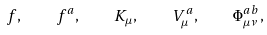<formula> <loc_0><loc_0><loc_500><loc_500>f , \quad f ^ { a } , \quad K _ { \mu } , \quad V _ { \mu } ^ { a } , \quad \Phi _ { \mu \nu } ^ { a b } ,</formula> 